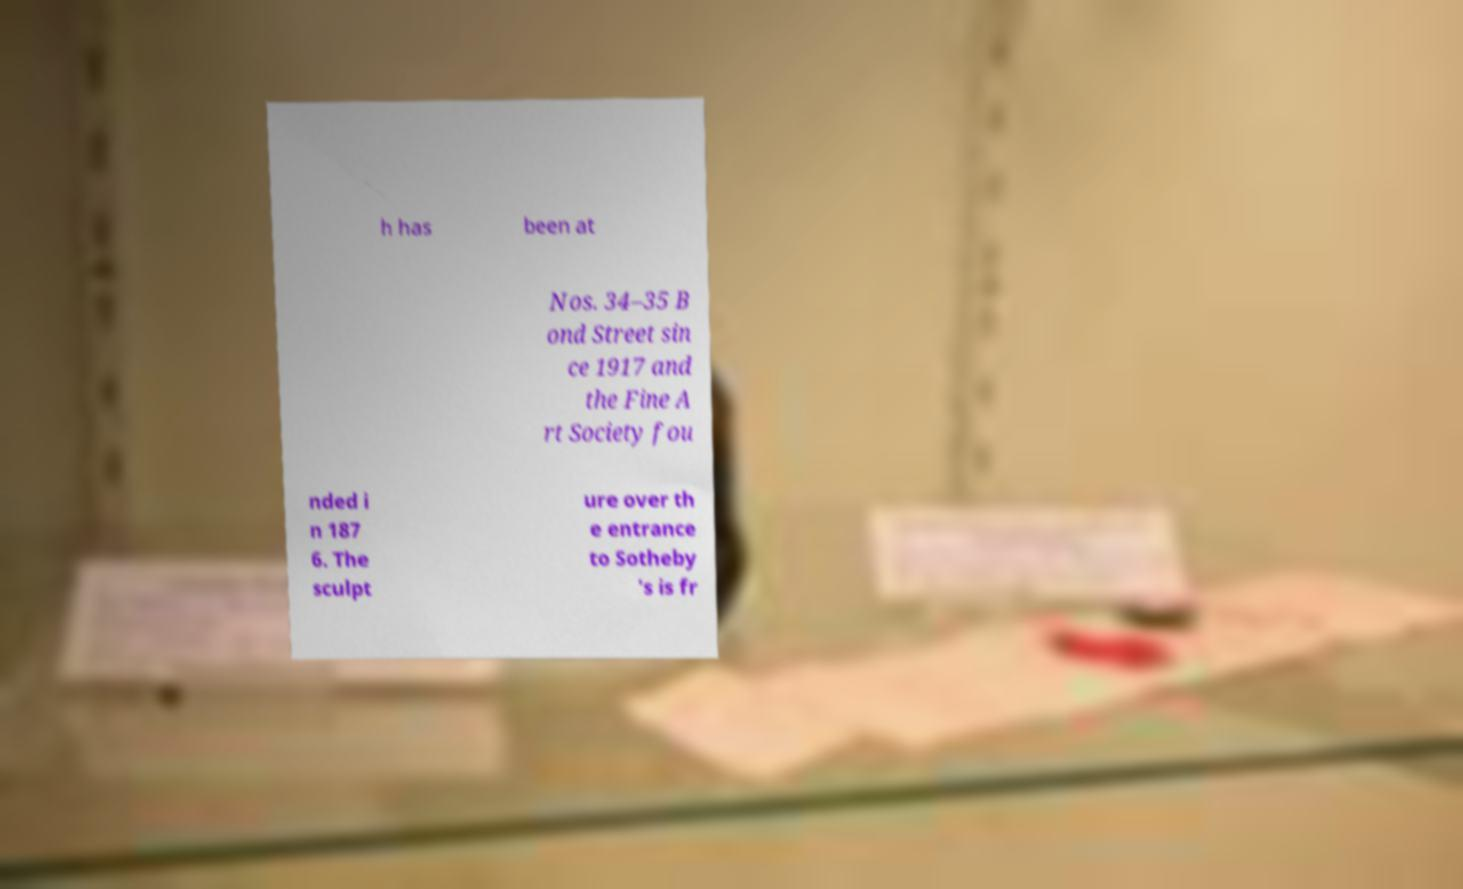Can you read and provide the text displayed in the image?This photo seems to have some interesting text. Can you extract and type it out for me? h has been at Nos. 34–35 B ond Street sin ce 1917 and the Fine A rt Society fou nded i n 187 6. The sculpt ure over th e entrance to Sotheby 's is fr 